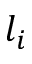<formula> <loc_0><loc_0><loc_500><loc_500>l _ { i }</formula> 